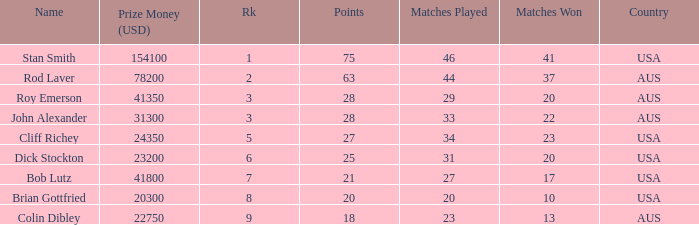How many matches did the player that played 23 matches win 13.0. 